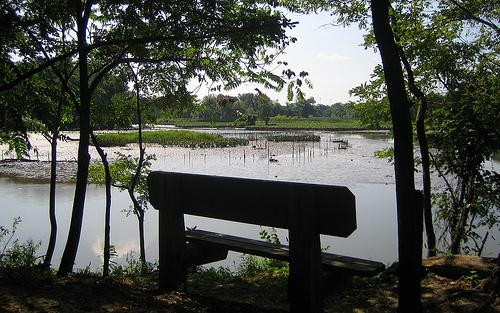Question: when was this photo taken?
Choices:
A. In the evening.
B. Last year.
C. During the day.
D. At Christmas.
Answer with the letter. Answer: C Question: what is in the foreground?
Choices:
A. A soccer ball.
B. A fireplace.
C. Bench.
D. An oil painting.
Answer with the letter. Answer: C 